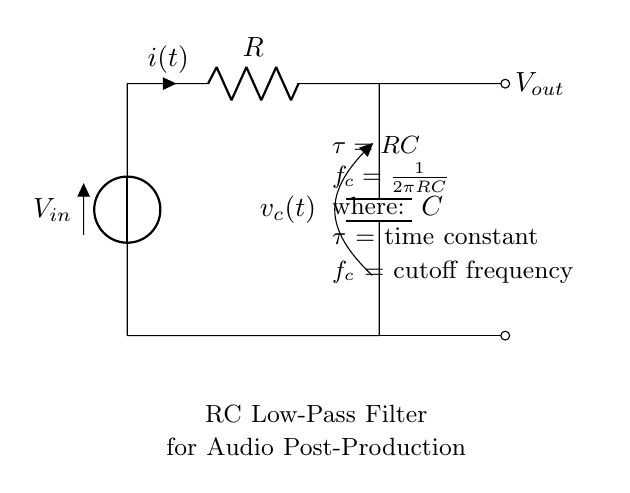What is the input voltage in this circuit? The input voltage is represented as V_in in the diagram, serving as the potential difference applied across the circuit.
Answer: V_in What does the resistor symbolize in this circuit? The resistor, labeled R, symbolizes a component that resists the flow of current, causing a voltage drop as per Ohm's law.
Answer: R What is the cutoff frequency formula shown in the diagram? The cutoff frequency formula is presented as f_c = 1/(2πRC), indicating the frequency at which the output voltage decreases significantly compared to the input.
Answer: f_c = 1/(2πRC) What is the time constant in this RC circuit? The time constant is denoted as τ, which is the product of resistance and capacitance (τ = RC), representing the time taken for the capacitor to charge to about 63% of V_in.
Answer: τ = RC How does increasing the resistance affect the cutoff frequency? Increasing the resistance (R) lowers the cutoff frequency (f_c), which means the circuit allows lower frequencies to pass through while attenuating higher frequencies more.
Answer: Lowers f_c What is the effect of capacitor size on audio filtering? A larger capacitor (C) increases the time constant (τ), allowing the circuit to filter lower frequencies, while a smaller capacitor allows higher frequencies to pass, making it less effective at filtering.
Answer: Filters lower frequencies What is the output voltage behavior in a low-pass filter at high frequencies? At high frequencies, the output voltage (V_out) decreases significantly due to the filtering action of the RC components, reflecting a key characteristic of low-pass filters where high frequencies are attenuated.
Answer: Decreases 